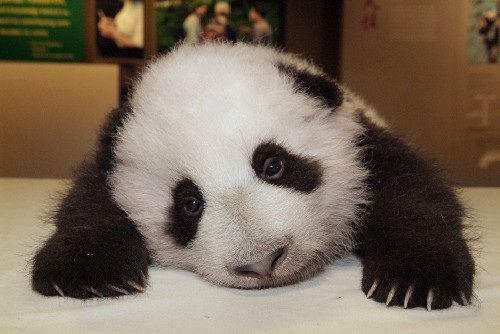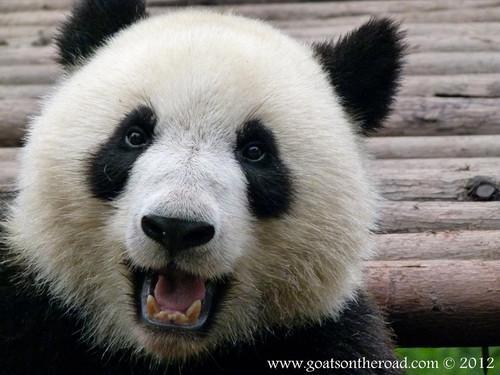The first image is the image on the left, the second image is the image on the right. Assess this claim about the two images: "In one of the images, a single panda is looking straight at the camera with its tongue visible.". Correct or not? Answer yes or no. Yes. The first image is the image on the left, the second image is the image on the right. Given the left and right images, does the statement "Both of one panda's front paws are extended forward and visible." hold true? Answer yes or no. Yes. 